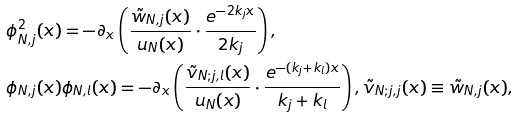<formula> <loc_0><loc_0><loc_500><loc_500>& \phi _ { N , j } ^ { 2 } ( x ) = - \partial _ { x } \left ( \frac { \tilde { w } _ { N , j } ( x ) } { u _ { N } ( x ) } \cdot \frac { e ^ { - 2 k _ { j } x } } { 2 k _ { j } } \right ) , \\ & \phi _ { N , j } ( x ) \phi _ { N , l } ( x ) = - \partial _ { x } \left ( \frac { \tilde { v } _ { N ; j , l } ( x ) } { u _ { N } ( x ) } \cdot \frac { e ^ { - ( k _ { j } + k _ { l } ) x } } { k _ { j } + k _ { l } } \right ) , \tilde { v } _ { N ; j , j } ( x ) \equiv \tilde { w } _ { N , j } ( x ) ,</formula> 